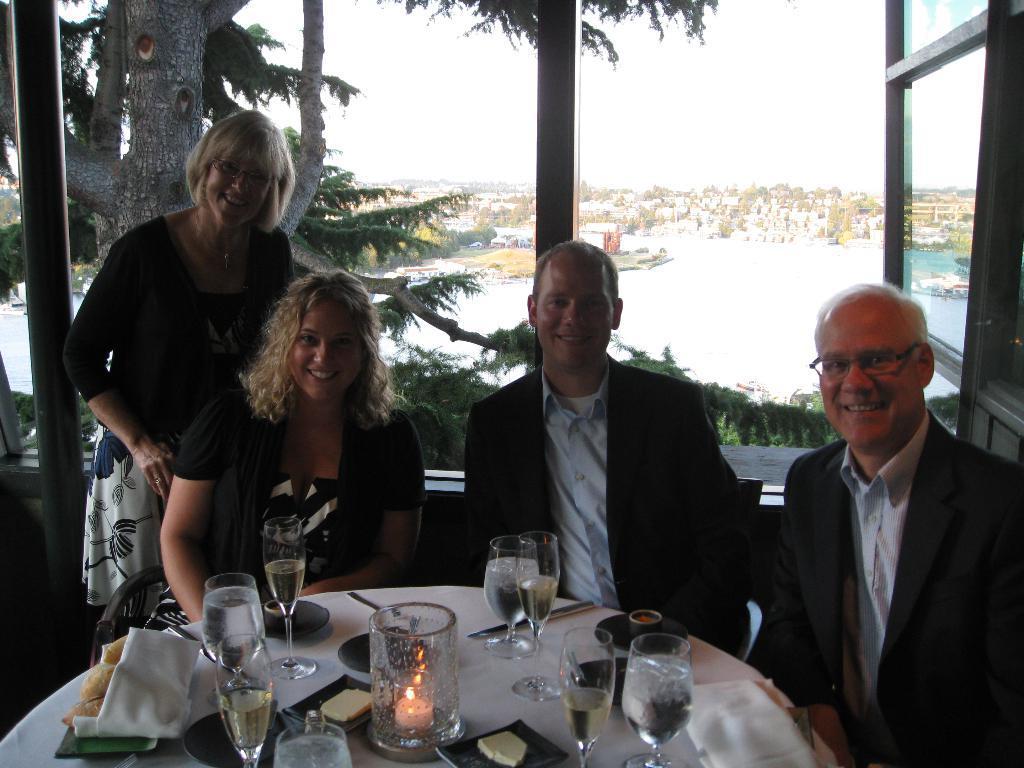Can you describe this image briefly? It is a table, there are drinks and water and a candle and some food and napkins and spoons on the table, there are four people sitting in front of the table two are men and two are woman all of them are smiling, in the background there is a window, sky , trees and water. 